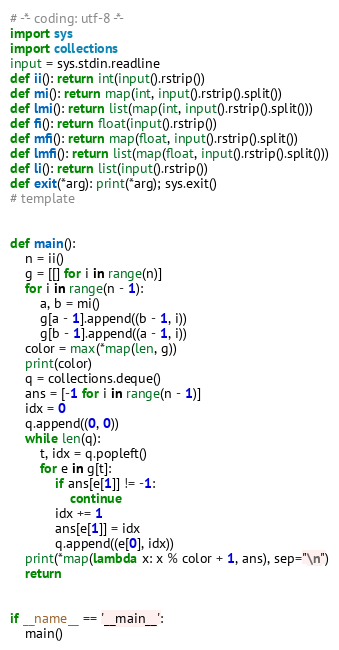<code> <loc_0><loc_0><loc_500><loc_500><_Python_># -*- coding: utf-8 -*-
import sys
import collections
input = sys.stdin.readline
def ii(): return int(input().rstrip())
def mi(): return map(int, input().rstrip().split())
def lmi(): return list(map(int, input().rstrip().split()))
def fi(): return float(input().rstrip())
def mfi(): return map(float, input().rstrip().split())
def lmfi(): return list(map(float, input().rstrip().split()))
def li(): return list(input().rstrip())
def exit(*arg): print(*arg); sys.exit()
# template


def main():
    n = ii()
    g = [[] for i in range(n)]
    for i in range(n - 1):
        a, b = mi()
        g[a - 1].append((b - 1, i))
        g[b - 1].append((a - 1, i))
    color = max(*map(len, g))
    print(color)
    q = collections.deque()
    ans = [-1 for i in range(n - 1)]
    idx = 0
    q.append((0, 0))
    while len(q):
        t, idx = q.popleft()
        for e in g[t]:
            if ans[e[1]] != -1:
                continue
            idx += 1
            ans[e[1]] = idx
            q.append((e[0], idx))
    print(*map(lambda x: x % color + 1, ans), sep="\n")
    return


if __name__ == '__main__':
    main()
</code> 